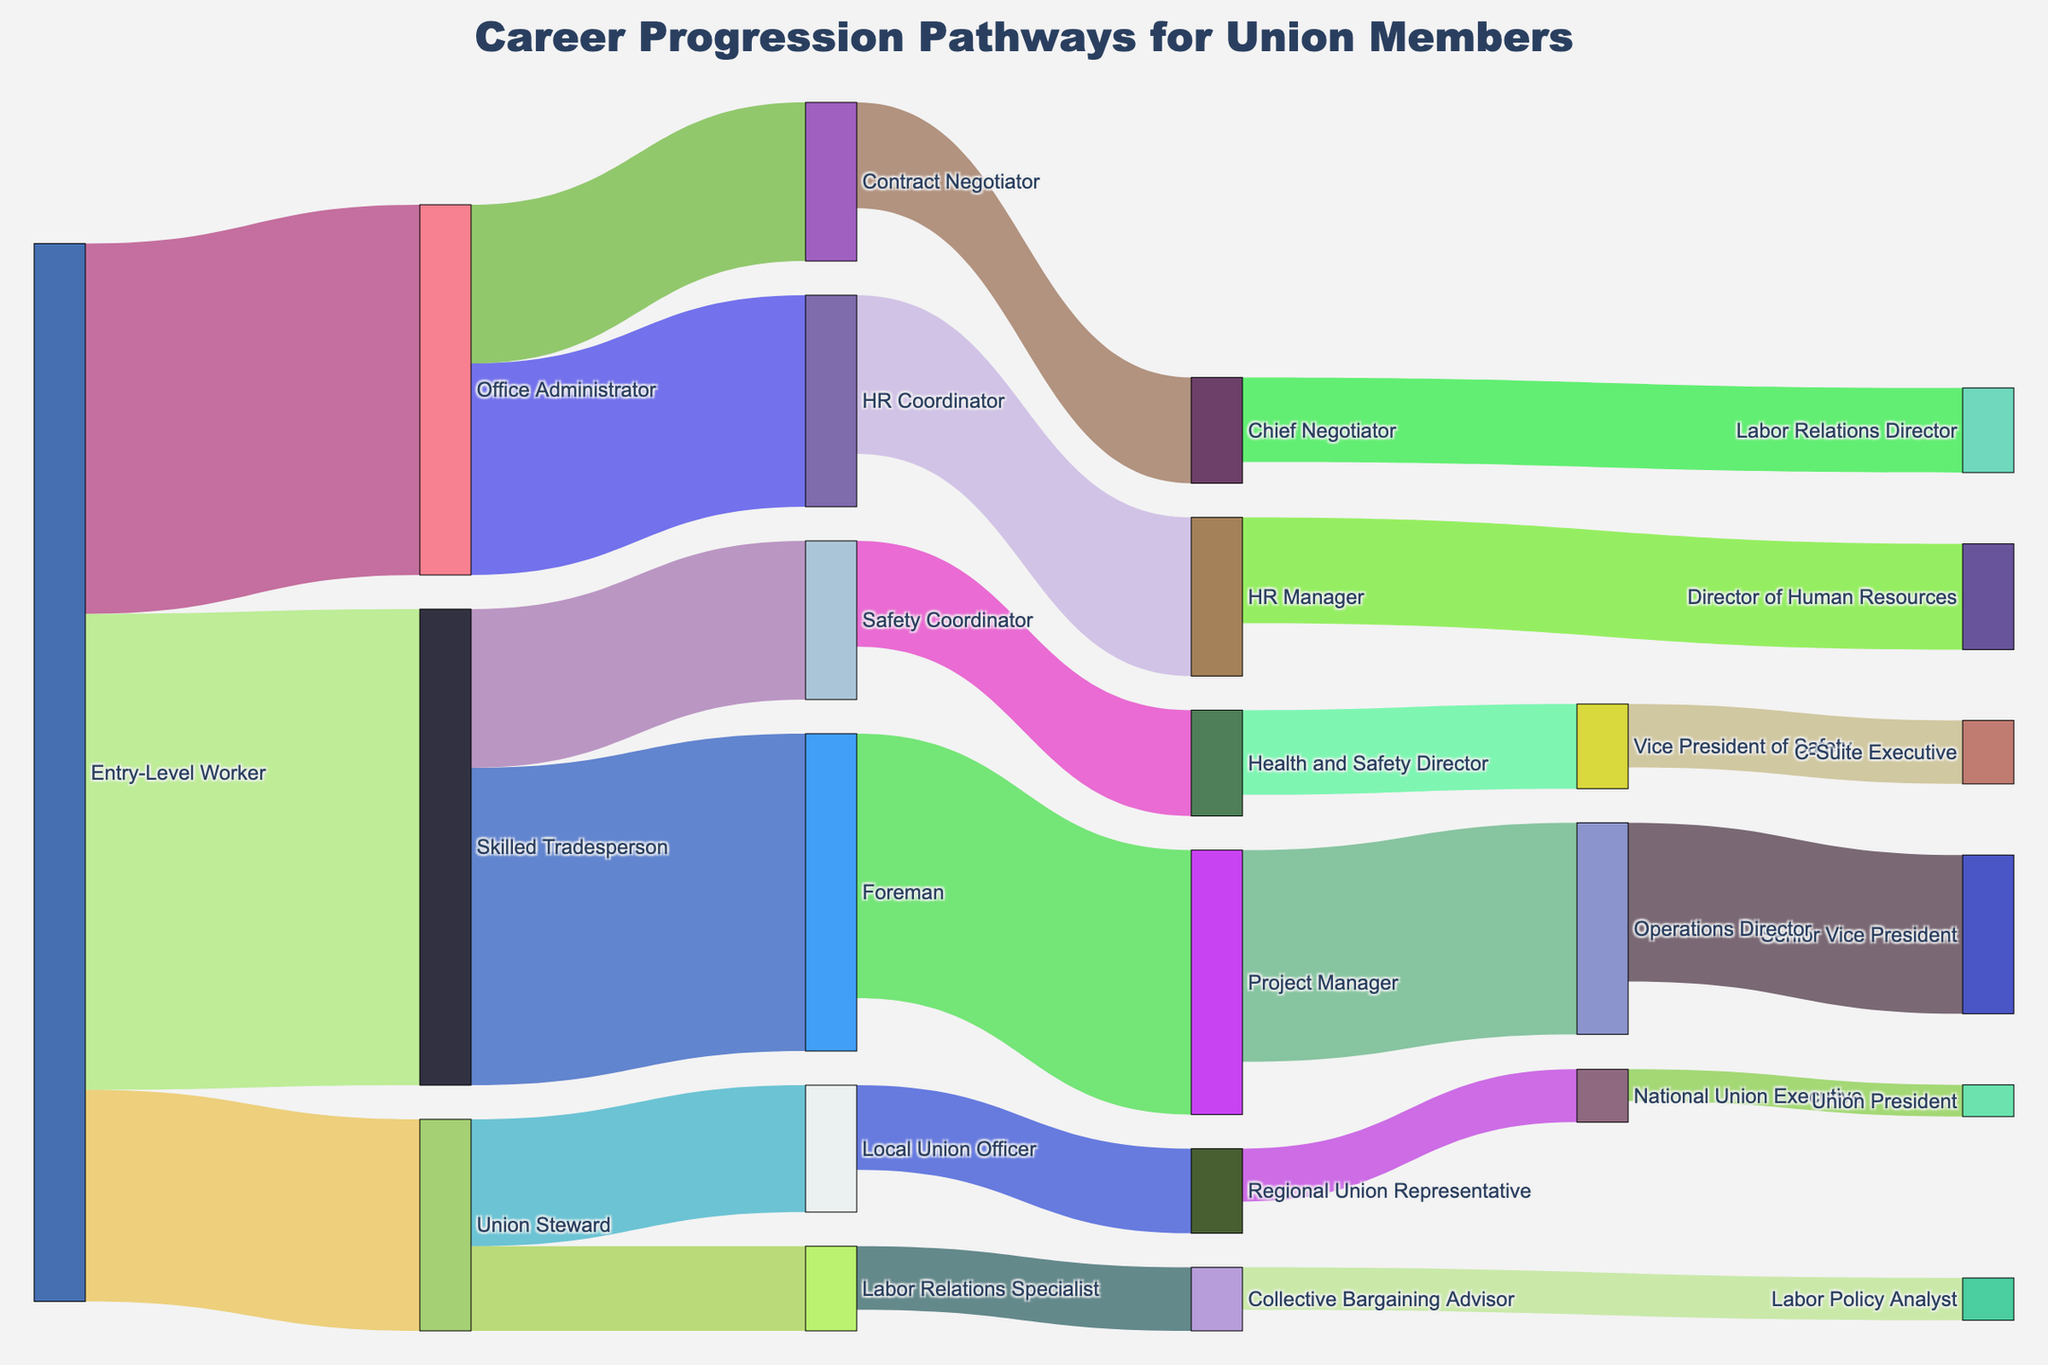What is the title of the diagram? The title is prominently displayed at the top of the figure.
Answer: Career Progression Pathways for Union Members How many career progression pathways are shown originating from an "Entry-Level Worker"? The pathways originating from an "Entry-Level Worker" are indicated by the links connecting from "Entry-Level Worker" to other roles. There are three such links.
Answer: 3 Which career progression pathway from "Entry-Level Worker" has the highest value? By inspecting the width of the links extending from "Entry-Level Worker," we can compare their sizes. The link to "Skilled Tradesperson" is the widest.
Answer: Skilled Tradesperson What is the progression step involving the highest value in the entire diagram? The width of the links throughout the diagram indicates their values. The link from "Entry-Level Worker" to "Skilled Tradesperson" is the widest.
Answer: Entry-Level Worker to Skilled Tradesperson How many pathways lead to "HR Manager"? By following the connections, we observe the links ending at "HR Manager." There is only one link going to "HR Manager."
Answer: 1 Which role has the next highest value progression from "Skilled Tradesperson"? Analyzing the links starting from "Skilled Tradesperson," the progression to "Foreman" has the largest width among them.
Answer: Foreman Sum the values of all career progression pathways leading to "Union Steward." Add the values of the links going to "Union Steward" (20 from "Entry-Level Worker").
Answer: 20 Compare the values of pathways leading to "Director of Human Resources" and "Vice President of Safety." Which is higher? The value for the pathway to "Director of Human Resources" is from "HR Manager" (10), and to "Vice President of Safety" is from "Health and Safety Director" (8). 10 is greater than 8.
Answer: Director of Human Resources How many roles in the diagram progress to some form of manager or director? Identify all roles with the titles "Manager", "Director", and higher. These include HR Manager, Director of Human Resources, Project Manager, Health and Safety Director, Vice President of Safety, Labor Relations Director, Operations Director, Senior Vice President, and C-Suite Executive. Count these distinct roles.
Answer: 9 What is the difference in value between the roles of "National Union Executive" and "Union President"? Look at the values: "National Union Executive" is 5 and "Union President" is 3. The difference is calculated by subtracting the smaller value from the larger one.
Answer: 2 